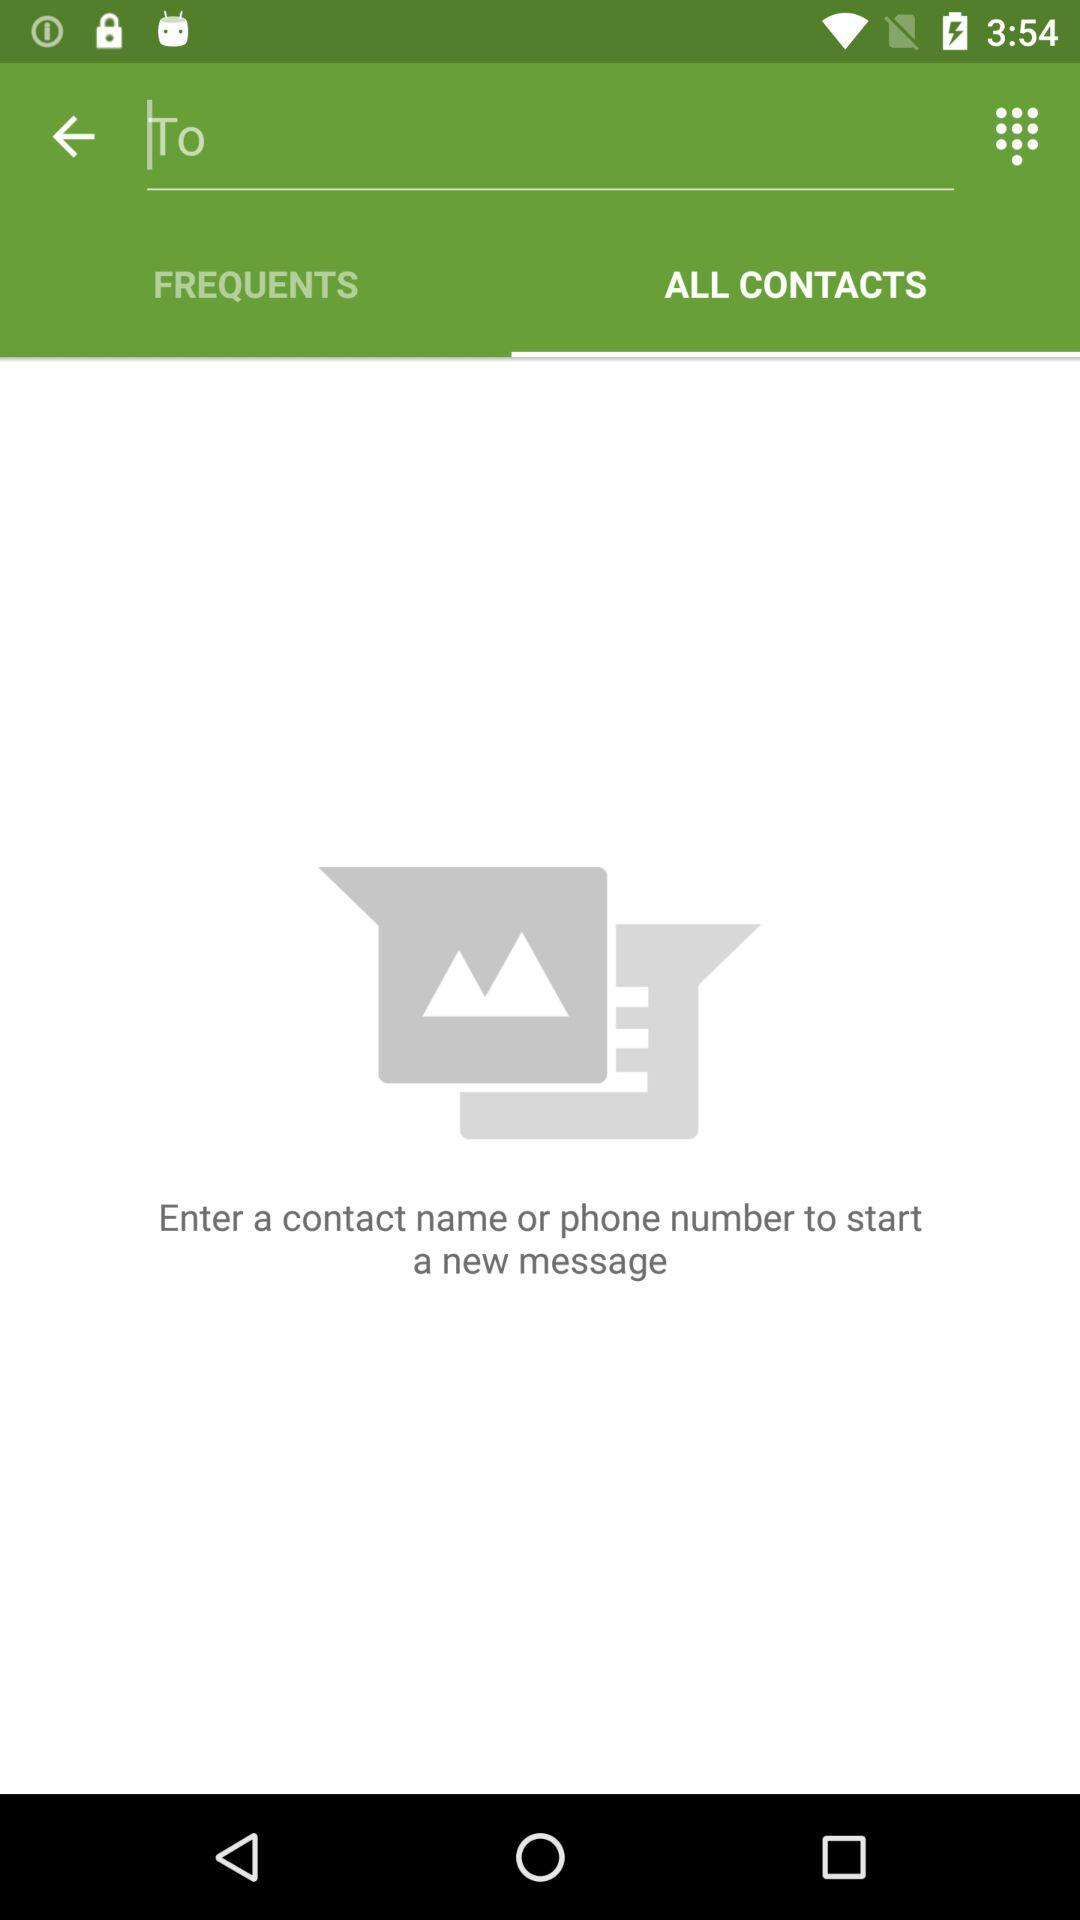Which tab is selected? The selected tab is "ALL CONTACTS". 